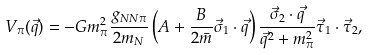Convert formula to latex. <formula><loc_0><loc_0><loc_500><loc_500>V _ { \pi } ( { \vec { q } } ) = - G m _ { \pi } ^ { 2 } \frac { g _ { N N \pi } } { 2 m _ { N } } \left ( A + \frac { B } { 2 \bar { m } } { \vec { \sigma } _ { 1 } } \cdot { \vec { q } } \right ) \frac { { \vec { \sigma } _ { 2 } } \cdot { \vec { q } } } { { \vec { q } } ^ { 2 } + m _ { \pi } ^ { 2 } } { \vec { \tau } _ { 1 } } \cdot { \vec { \tau } _ { 2 } } ,</formula> 